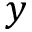Convert formula to latex. <formula><loc_0><loc_0><loc_500><loc_500>y</formula> 